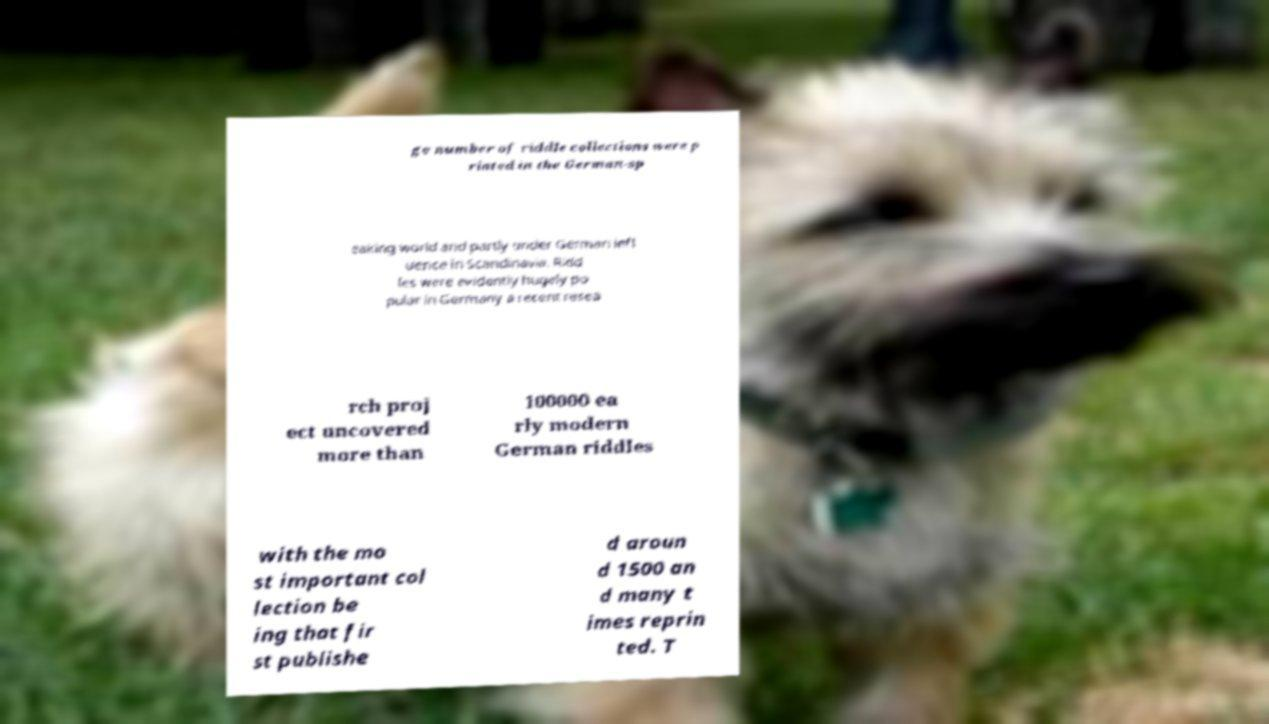Can you accurately transcribe the text from the provided image for me? ge number of riddle collections were p rinted in the German-sp eaking world and partly under German infl uence in Scandinavia. Ridd les were evidently hugely po pular in Germany a recent resea rch proj ect uncovered more than 100000 ea rly modern German riddles with the mo st important col lection be ing that fir st publishe d aroun d 1500 an d many t imes reprin ted. T 